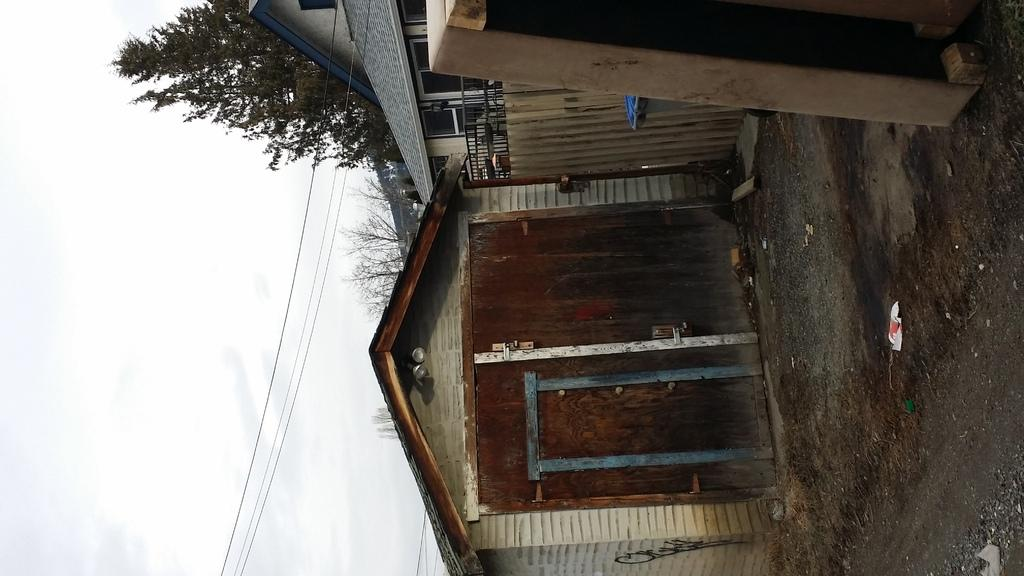What type of structures can be seen in the image? There are buildings in the image. What feature is common to many of the buildings? There are windows in the image. What architectural element can be seen in the image? There is a railing in the image. What type of vegetation is present in the image? There are trees in the image. What man-made objects can be seen in the image? There are wires in the image. What is the color of the sky in the image? The sky is white and blue in color. Where is the toothpaste located in the image? There is no toothpaste present in the image. What type of land can be seen in the image? The image does not show any specific type of land; it primarily features buildings, trees, and the sky. 